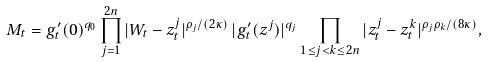<formula> <loc_0><loc_0><loc_500><loc_500>M _ { t } = g ^ { \prime } _ { t } ( 0 ) ^ { q _ { 0 } } \prod _ { j = 1 } ^ { 2 n } | W _ { t } - z ^ { j } _ { t } | ^ { \rho _ { j } / ( 2 \kappa ) } \, | g _ { t } ^ { \prime } ( z ^ { j } ) | ^ { q _ { j } } \prod _ { 1 \leq j < k \leq 2 n } | z _ { t } ^ { j } - z _ { t } ^ { k } | ^ { \rho _ { j } \rho _ { k } / ( 8 \kappa ) } ,</formula> 